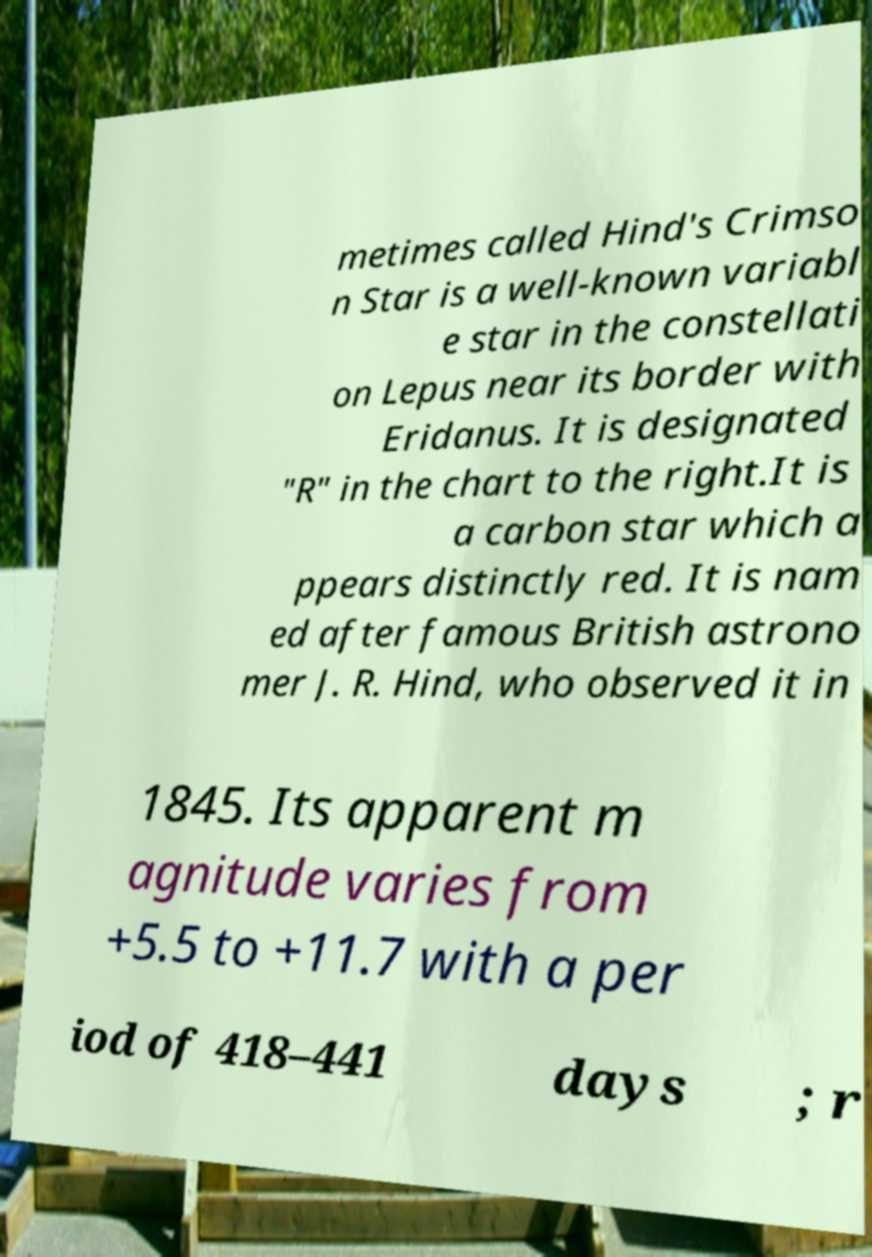What messages or text are displayed in this image? I need them in a readable, typed format. metimes called Hind's Crimso n Star is a well-known variabl e star in the constellati on Lepus near its border with Eridanus. It is designated "R" in the chart to the right.It is a carbon star which a ppears distinctly red. It is nam ed after famous British astrono mer J. R. Hind, who observed it in 1845. Its apparent m agnitude varies from +5.5 to +11.7 with a per iod of 418–441 days ; r 